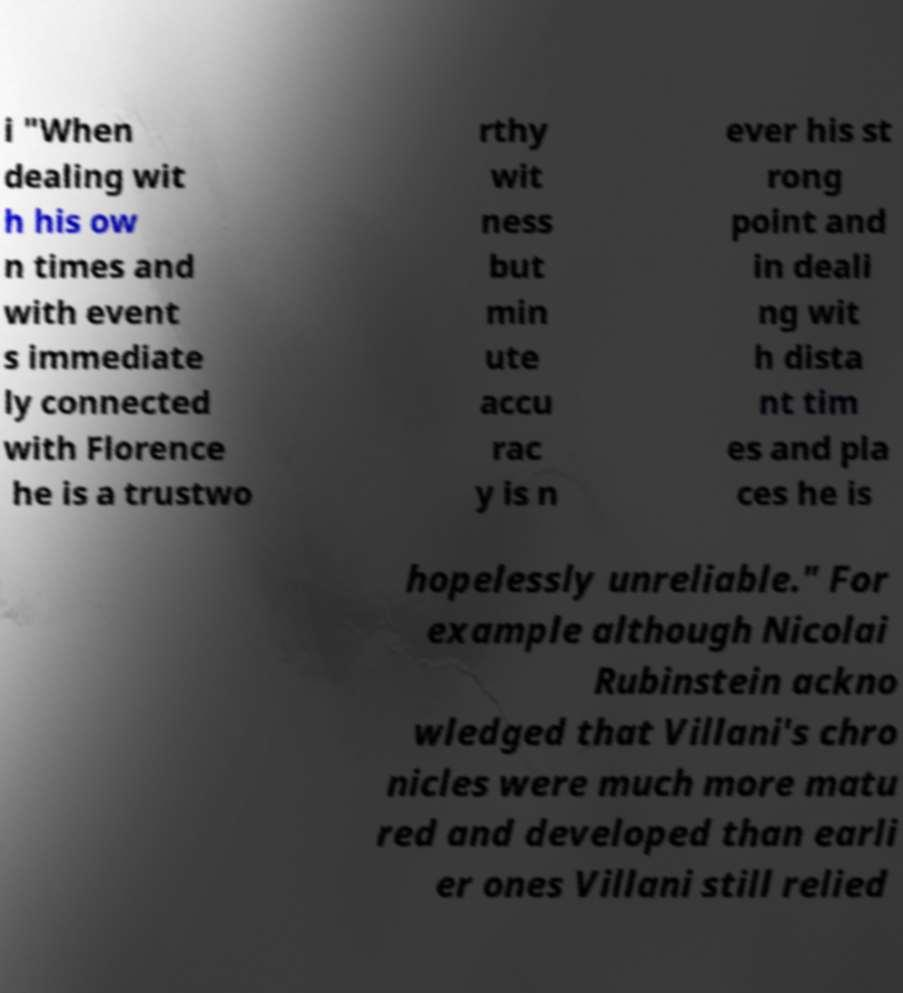Could you assist in decoding the text presented in this image and type it out clearly? i "When dealing wit h his ow n times and with event s immediate ly connected with Florence he is a trustwo rthy wit ness but min ute accu rac y is n ever his st rong point and in deali ng wit h dista nt tim es and pla ces he is hopelessly unreliable." For example although Nicolai Rubinstein ackno wledged that Villani's chro nicles were much more matu red and developed than earli er ones Villani still relied 